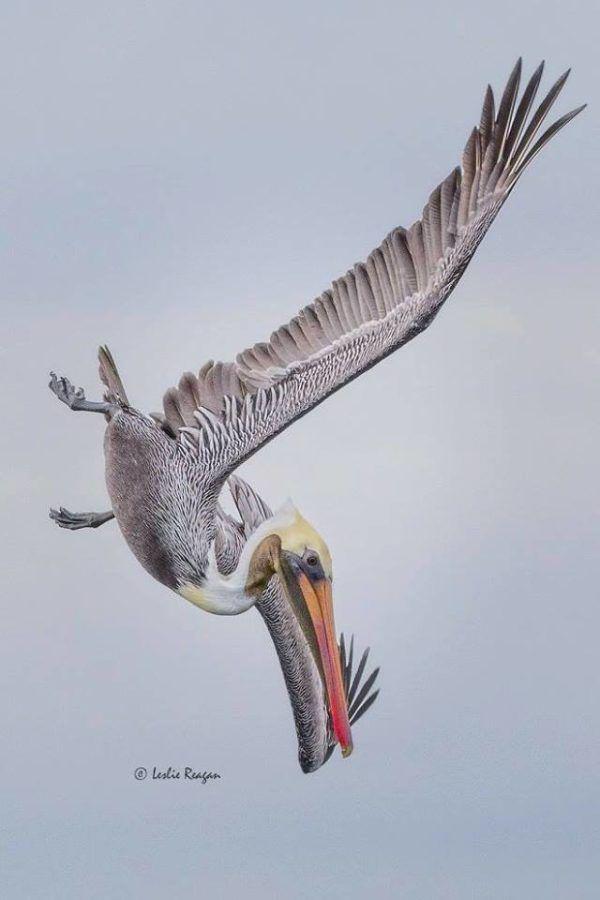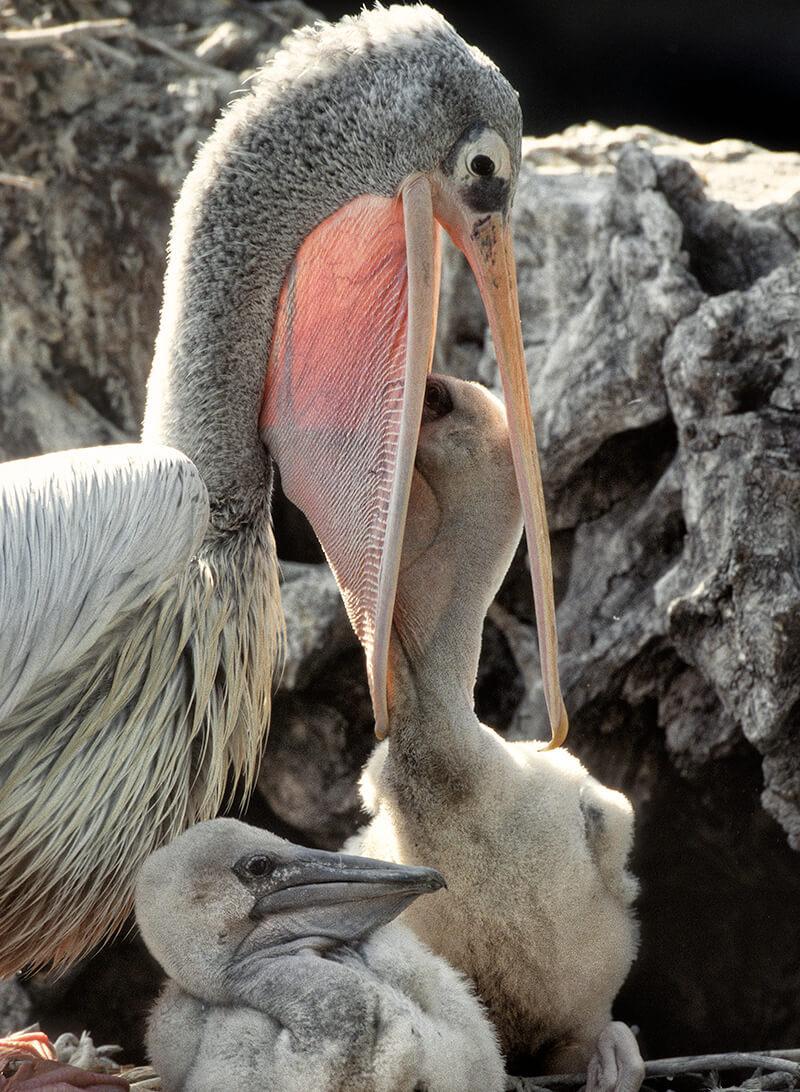The first image is the image on the left, the second image is the image on the right. Examine the images to the left and right. Is the description "There are more pelican birds in the right image than in the left." accurate? Answer yes or no. Yes. 